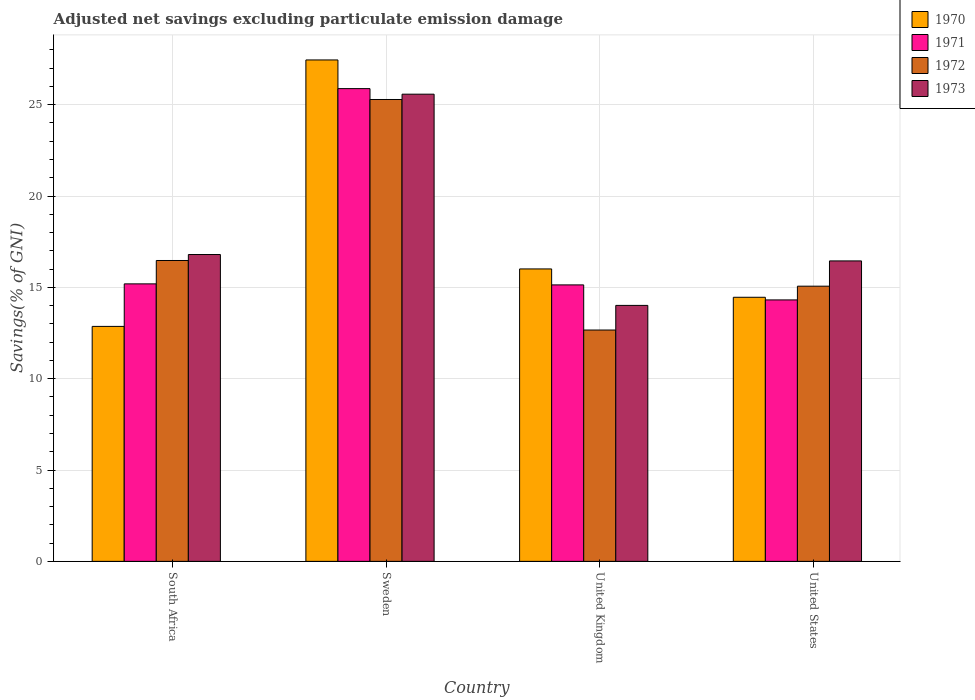How many groups of bars are there?
Your answer should be compact. 4. Are the number of bars per tick equal to the number of legend labels?
Provide a short and direct response. Yes. How many bars are there on the 2nd tick from the left?
Provide a short and direct response. 4. How many bars are there on the 2nd tick from the right?
Your answer should be very brief. 4. In how many cases, is the number of bars for a given country not equal to the number of legend labels?
Your response must be concise. 0. What is the adjusted net savings in 1972 in South Africa?
Offer a terse response. 16.47. Across all countries, what is the maximum adjusted net savings in 1972?
Make the answer very short. 25.28. Across all countries, what is the minimum adjusted net savings in 1971?
Offer a very short reply. 14.31. In which country was the adjusted net savings in 1970 minimum?
Your answer should be very brief. South Africa. What is the total adjusted net savings in 1971 in the graph?
Your response must be concise. 70.51. What is the difference between the adjusted net savings in 1973 in Sweden and that in United States?
Keep it short and to the point. 9.13. What is the difference between the adjusted net savings in 1971 in Sweden and the adjusted net savings in 1973 in United States?
Provide a succinct answer. 9.43. What is the average adjusted net savings in 1972 per country?
Make the answer very short. 17.37. What is the difference between the adjusted net savings of/in 1973 and adjusted net savings of/in 1971 in Sweden?
Ensure brevity in your answer.  -0.3. In how many countries, is the adjusted net savings in 1971 greater than 18 %?
Offer a terse response. 1. What is the ratio of the adjusted net savings in 1970 in South Africa to that in United Kingdom?
Keep it short and to the point. 0.8. Is the adjusted net savings in 1973 in South Africa less than that in Sweden?
Provide a short and direct response. Yes. Is the difference between the adjusted net savings in 1973 in South Africa and Sweden greater than the difference between the adjusted net savings in 1971 in South Africa and Sweden?
Offer a terse response. Yes. What is the difference between the highest and the second highest adjusted net savings in 1970?
Provide a short and direct response. -11.44. What is the difference between the highest and the lowest adjusted net savings in 1970?
Offer a very short reply. 14.59. In how many countries, is the adjusted net savings in 1970 greater than the average adjusted net savings in 1970 taken over all countries?
Provide a succinct answer. 1. What does the 1st bar from the right in United States represents?
Offer a very short reply. 1973. Is it the case that in every country, the sum of the adjusted net savings in 1973 and adjusted net savings in 1971 is greater than the adjusted net savings in 1970?
Your response must be concise. Yes. How many bars are there?
Give a very brief answer. 16. How many countries are there in the graph?
Give a very brief answer. 4. What is the difference between two consecutive major ticks on the Y-axis?
Offer a terse response. 5. Are the values on the major ticks of Y-axis written in scientific E-notation?
Provide a succinct answer. No. How are the legend labels stacked?
Keep it short and to the point. Vertical. What is the title of the graph?
Keep it short and to the point. Adjusted net savings excluding particulate emission damage. Does "1973" appear as one of the legend labels in the graph?
Provide a succinct answer. Yes. What is the label or title of the X-axis?
Provide a succinct answer. Country. What is the label or title of the Y-axis?
Offer a very short reply. Savings(% of GNI). What is the Savings(% of GNI) of 1970 in South Africa?
Your answer should be compact. 12.86. What is the Savings(% of GNI) of 1971 in South Africa?
Provide a short and direct response. 15.19. What is the Savings(% of GNI) of 1972 in South Africa?
Keep it short and to the point. 16.47. What is the Savings(% of GNI) of 1973 in South Africa?
Offer a very short reply. 16.8. What is the Savings(% of GNI) in 1970 in Sweden?
Provide a short and direct response. 27.45. What is the Savings(% of GNI) in 1971 in Sweden?
Your answer should be compact. 25.88. What is the Savings(% of GNI) of 1972 in Sweden?
Give a very brief answer. 25.28. What is the Savings(% of GNI) in 1973 in Sweden?
Your answer should be compact. 25.57. What is the Savings(% of GNI) of 1970 in United Kingdom?
Your response must be concise. 16.01. What is the Savings(% of GNI) in 1971 in United Kingdom?
Keep it short and to the point. 15.13. What is the Savings(% of GNI) in 1972 in United Kingdom?
Make the answer very short. 12.66. What is the Savings(% of GNI) of 1973 in United Kingdom?
Your answer should be very brief. 14.01. What is the Savings(% of GNI) in 1970 in United States?
Give a very brief answer. 14.46. What is the Savings(% of GNI) in 1971 in United States?
Offer a very short reply. 14.31. What is the Savings(% of GNI) in 1972 in United States?
Give a very brief answer. 15.06. What is the Savings(% of GNI) in 1973 in United States?
Give a very brief answer. 16.45. Across all countries, what is the maximum Savings(% of GNI) in 1970?
Ensure brevity in your answer.  27.45. Across all countries, what is the maximum Savings(% of GNI) of 1971?
Offer a terse response. 25.88. Across all countries, what is the maximum Savings(% of GNI) in 1972?
Provide a short and direct response. 25.28. Across all countries, what is the maximum Savings(% of GNI) of 1973?
Your answer should be compact. 25.57. Across all countries, what is the minimum Savings(% of GNI) of 1970?
Give a very brief answer. 12.86. Across all countries, what is the minimum Savings(% of GNI) of 1971?
Offer a very short reply. 14.31. Across all countries, what is the minimum Savings(% of GNI) in 1972?
Give a very brief answer. 12.66. Across all countries, what is the minimum Savings(% of GNI) in 1973?
Provide a succinct answer. 14.01. What is the total Savings(% of GNI) in 1970 in the graph?
Your answer should be very brief. 70.77. What is the total Savings(% of GNI) in 1971 in the graph?
Your answer should be very brief. 70.51. What is the total Savings(% of GNI) of 1972 in the graph?
Provide a succinct answer. 69.48. What is the total Savings(% of GNI) of 1973 in the graph?
Provide a succinct answer. 72.83. What is the difference between the Savings(% of GNI) of 1970 in South Africa and that in Sweden?
Offer a very short reply. -14.59. What is the difference between the Savings(% of GNI) in 1971 in South Africa and that in Sweden?
Provide a short and direct response. -10.69. What is the difference between the Savings(% of GNI) in 1972 in South Africa and that in Sweden?
Provide a short and direct response. -8.81. What is the difference between the Savings(% of GNI) of 1973 in South Africa and that in Sweden?
Offer a terse response. -8.78. What is the difference between the Savings(% of GNI) of 1970 in South Africa and that in United Kingdom?
Your response must be concise. -3.15. What is the difference between the Savings(% of GNI) of 1971 in South Africa and that in United Kingdom?
Keep it short and to the point. 0.06. What is the difference between the Savings(% of GNI) in 1972 in South Africa and that in United Kingdom?
Give a very brief answer. 3.81. What is the difference between the Savings(% of GNI) of 1973 in South Africa and that in United Kingdom?
Offer a very short reply. 2.78. What is the difference between the Savings(% of GNI) in 1970 in South Africa and that in United States?
Ensure brevity in your answer.  -1.59. What is the difference between the Savings(% of GNI) in 1971 in South Africa and that in United States?
Ensure brevity in your answer.  0.88. What is the difference between the Savings(% of GNI) in 1972 in South Africa and that in United States?
Offer a terse response. 1.41. What is the difference between the Savings(% of GNI) of 1973 in South Africa and that in United States?
Make the answer very short. 0.35. What is the difference between the Savings(% of GNI) in 1970 in Sweden and that in United Kingdom?
Your answer should be very brief. 11.44. What is the difference between the Savings(% of GNI) in 1971 in Sweden and that in United Kingdom?
Your response must be concise. 10.74. What is the difference between the Savings(% of GNI) of 1972 in Sweden and that in United Kingdom?
Provide a succinct answer. 12.62. What is the difference between the Savings(% of GNI) in 1973 in Sweden and that in United Kingdom?
Your response must be concise. 11.56. What is the difference between the Savings(% of GNI) of 1970 in Sweden and that in United States?
Give a very brief answer. 12.99. What is the difference between the Savings(% of GNI) of 1971 in Sweden and that in United States?
Provide a succinct answer. 11.57. What is the difference between the Savings(% of GNI) in 1972 in Sweden and that in United States?
Offer a very short reply. 10.22. What is the difference between the Savings(% of GNI) in 1973 in Sweden and that in United States?
Ensure brevity in your answer.  9.13. What is the difference between the Savings(% of GNI) in 1970 in United Kingdom and that in United States?
Keep it short and to the point. 1.55. What is the difference between the Savings(% of GNI) in 1971 in United Kingdom and that in United States?
Provide a succinct answer. 0.82. What is the difference between the Savings(% of GNI) in 1972 in United Kingdom and that in United States?
Your answer should be compact. -2.4. What is the difference between the Savings(% of GNI) in 1973 in United Kingdom and that in United States?
Provide a succinct answer. -2.43. What is the difference between the Savings(% of GNI) in 1970 in South Africa and the Savings(% of GNI) in 1971 in Sweden?
Ensure brevity in your answer.  -13.02. What is the difference between the Savings(% of GNI) in 1970 in South Africa and the Savings(% of GNI) in 1972 in Sweden?
Give a very brief answer. -12.42. What is the difference between the Savings(% of GNI) in 1970 in South Africa and the Savings(% of GNI) in 1973 in Sweden?
Ensure brevity in your answer.  -12.71. What is the difference between the Savings(% of GNI) in 1971 in South Africa and the Savings(% of GNI) in 1972 in Sweden?
Offer a very short reply. -10.09. What is the difference between the Savings(% of GNI) of 1971 in South Africa and the Savings(% of GNI) of 1973 in Sweden?
Your response must be concise. -10.38. What is the difference between the Savings(% of GNI) in 1972 in South Africa and the Savings(% of GNI) in 1973 in Sweden?
Keep it short and to the point. -9.1. What is the difference between the Savings(% of GNI) in 1970 in South Africa and the Savings(% of GNI) in 1971 in United Kingdom?
Offer a very short reply. -2.27. What is the difference between the Savings(% of GNI) in 1970 in South Africa and the Savings(% of GNI) in 1972 in United Kingdom?
Your answer should be compact. 0.2. What is the difference between the Savings(% of GNI) in 1970 in South Africa and the Savings(% of GNI) in 1973 in United Kingdom?
Provide a succinct answer. -1.15. What is the difference between the Savings(% of GNI) in 1971 in South Africa and the Savings(% of GNI) in 1972 in United Kingdom?
Provide a succinct answer. 2.53. What is the difference between the Savings(% of GNI) in 1971 in South Africa and the Savings(% of GNI) in 1973 in United Kingdom?
Keep it short and to the point. 1.18. What is the difference between the Savings(% of GNI) of 1972 in South Africa and the Savings(% of GNI) of 1973 in United Kingdom?
Keep it short and to the point. 2.46. What is the difference between the Savings(% of GNI) in 1970 in South Africa and the Savings(% of GNI) in 1971 in United States?
Offer a terse response. -1.45. What is the difference between the Savings(% of GNI) in 1970 in South Africa and the Savings(% of GNI) in 1972 in United States?
Keep it short and to the point. -2.2. What is the difference between the Savings(% of GNI) of 1970 in South Africa and the Savings(% of GNI) of 1973 in United States?
Keep it short and to the point. -3.58. What is the difference between the Savings(% of GNI) in 1971 in South Africa and the Savings(% of GNI) in 1972 in United States?
Your answer should be compact. 0.13. What is the difference between the Savings(% of GNI) in 1971 in South Africa and the Savings(% of GNI) in 1973 in United States?
Provide a short and direct response. -1.26. What is the difference between the Savings(% of GNI) in 1972 in South Africa and the Savings(% of GNI) in 1973 in United States?
Provide a short and direct response. 0.02. What is the difference between the Savings(% of GNI) in 1970 in Sweden and the Savings(% of GNI) in 1971 in United Kingdom?
Make the answer very short. 12.31. What is the difference between the Savings(% of GNI) in 1970 in Sweden and the Savings(% of GNI) in 1972 in United Kingdom?
Your answer should be compact. 14.78. What is the difference between the Savings(% of GNI) of 1970 in Sweden and the Savings(% of GNI) of 1973 in United Kingdom?
Provide a short and direct response. 13.44. What is the difference between the Savings(% of GNI) in 1971 in Sweden and the Savings(% of GNI) in 1972 in United Kingdom?
Ensure brevity in your answer.  13.21. What is the difference between the Savings(% of GNI) in 1971 in Sweden and the Savings(% of GNI) in 1973 in United Kingdom?
Give a very brief answer. 11.87. What is the difference between the Savings(% of GNI) in 1972 in Sweden and the Savings(% of GNI) in 1973 in United Kingdom?
Offer a terse response. 11.27. What is the difference between the Savings(% of GNI) of 1970 in Sweden and the Savings(% of GNI) of 1971 in United States?
Give a very brief answer. 13.14. What is the difference between the Savings(% of GNI) in 1970 in Sweden and the Savings(% of GNI) in 1972 in United States?
Your answer should be compact. 12.38. What is the difference between the Savings(% of GNI) in 1970 in Sweden and the Savings(% of GNI) in 1973 in United States?
Provide a short and direct response. 11. What is the difference between the Savings(% of GNI) of 1971 in Sweden and the Savings(% of GNI) of 1972 in United States?
Provide a short and direct response. 10.81. What is the difference between the Savings(% of GNI) of 1971 in Sweden and the Savings(% of GNI) of 1973 in United States?
Ensure brevity in your answer.  9.43. What is the difference between the Savings(% of GNI) in 1972 in Sweden and the Savings(% of GNI) in 1973 in United States?
Make the answer very short. 8.84. What is the difference between the Savings(% of GNI) in 1970 in United Kingdom and the Savings(% of GNI) in 1971 in United States?
Keep it short and to the point. 1.7. What is the difference between the Savings(% of GNI) of 1970 in United Kingdom and the Savings(% of GNI) of 1972 in United States?
Your answer should be very brief. 0.94. What is the difference between the Savings(% of GNI) in 1970 in United Kingdom and the Savings(% of GNI) in 1973 in United States?
Your answer should be very brief. -0.44. What is the difference between the Savings(% of GNI) in 1971 in United Kingdom and the Savings(% of GNI) in 1972 in United States?
Your answer should be compact. 0.07. What is the difference between the Savings(% of GNI) in 1971 in United Kingdom and the Savings(% of GNI) in 1973 in United States?
Offer a very short reply. -1.31. What is the difference between the Savings(% of GNI) in 1972 in United Kingdom and the Savings(% of GNI) in 1973 in United States?
Offer a very short reply. -3.78. What is the average Savings(% of GNI) in 1970 per country?
Ensure brevity in your answer.  17.69. What is the average Savings(% of GNI) of 1971 per country?
Provide a short and direct response. 17.63. What is the average Savings(% of GNI) in 1972 per country?
Your response must be concise. 17.37. What is the average Savings(% of GNI) in 1973 per country?
Make the answer very short. 18.21. What is the difference between the Savings(% of GNI) of 1970 and Savings(% of GNI) of 1971 in South Africa?
Make the answer very short. -2.33. What is the difference between the Savings(% of GNI) of 1970 and Savings(% of GNI) of 1972 in South Africa?
Offer a very short reply. -3.61. What is the difference between the Savings(% of GNI) of 1970 and Savings(% of GNI) of 1973 in South Africa?
Ensure brevity in your answer.  -3.93. What is the difference between the Savings(% of GNI) in 1971 and Savings(% of GNI) in 1972 in South Africa?
Keep it short and to the point. -1.28. What is the difference between the Savings(% of GNI) in 1971 and Savings(% of GNI) in 1973 in South Africa?
Your response must be concise. -1.61. What is the difference between the Savings(% of GNI) in 1972 and Savings(% of GNI) in 1973 in South Africa?
Offer a very short reply. -0.33. What is the difference between the Savings(% of GNI) of 1970 and Savings(% of GNI) of 1971 in Sweden?
Make the answer very short. 1.57. What is the difference between the Savings(% of GNI) in 1970 and Savings(% of GNI) in 1972 in Sweden?
Provide a succinct answer. 2.16. What is the difference between the Savings(% of GNI) of 1970 and Savings(% of GNI) of 1973 in Sweden?
Your response must be concise. 1.87. What is the difference between the Savings(% of GNI) in 1971 and Savings(% of GNI) in 1972 in Sweden?
Your response must be concise. 0.59. What is the difference between the Savings(% of GNI) in 1971 and Savings(% of GNI) in 1973 in Sweden?
Offer a terse response. 0.3. What is the difference between the Savings(% of GNI) of 1972 and Savings(% of GNI) of 1973 in Sweden?
Give a very brief answer. -0.29. What is the difference between the Savings(% of GNI) of 1970 and Savings(% of GNI) of 1971 in United Kingdom?
Keep it short and to the point. 0.87. What is the difference between the Savings(% of GNI) in 1970 and Savings(% of GNI) in 1972 in United Kingdom?
Give a very brief answer. 3.34. What is the difference between the Savings(% of GNI) in 1970 and Savings(% of GNI) in 1973 in United Kingdom?
Ensure brevity in your answer.  2. What is the difference between the Savings(% of GNI) in 1971 and Savings(% of GNI) in 1972 in United Kingdom?
Provide a short and direct response. 2.47. What is the difference between the Savings(% of GNI) of 1971 and Savings(% of GNI) of 1973 in United Kingdom?
Offer a terse response. 1.12. What is the difference between the Savings(% of GNI) in 1972 and Savings(% of GNI) in 1973 in United Kingdom?
Keep it short and to the point. -1.35. What is the difference between the Savings(% of GNI) of 1970 and Savings(% of GNI) of 1971 in United States?
Your answer should be very brief. 0.14. What is the difference between the Savings(% of GNI) of 1970 and Savings(% of GNI) of 1972 in United States?
Make the answer very short. -0.61. What is the difference between the Savings(% of GNI) of 1970 and Savings(% of GNI) of 1973 in United States?
Give a very brief answer. -1.99. What is the difference between the Savings(% of GNI) of 1971 and Savings(% of GNI) of 1972 in United States?
Keep it short and to the point. -0.75. What is the difference between the Savings(% of GNI) in 1971 and Savings(% of GNI) in 1973 in United States?
Offer a very short reply. -2.13. What is the difference between the Savings(% of GNI) of 1972 and Savings(% of GNI) of 1973 in United States?
Offer a very short reply. -1.38. What is the ratio of the Savings(% of GNI) in 1970 in South Africa to that in Sweden?
Provide a succinct answer. 0.47. What is the ratio of the Savings(% of GNI) of 1971 in South Africa to that in Sweden?
Provide a succinct answer. 0.59. What is the ratio of the Savings(% of GNI) of 1972 in South Africa to that in Sweden?
Provide a succinct answer. 0.65. What is the ratio of the Savings(% of GNI) of 1973 in South Africa to that in Sweden?
Provide a succinct answer. 0.66. What is the ratio of the Savings(% of GNI) in 1970 in South Africa to that in United Kingdom?
Make the answer very short. 0.8. What is the ratio of the Savings(% of GNI) of 1972 in South Africa to that in United Kingdom?
Your response must be concise. 1.3. What is the ratio of the Savings(% of GNI) in 1973 in South Africa to that in United Kingdom?
Your response must be concise. 1.2. What is the ratio of the Savings(% of GNI) in 1970 in South Africa to that in United States?
Provide a short and direct response. 0.89. What is the ratio of the Savings(% of GNI) in 1971 in South Africa to that in United States?
Offer a terse response. 1.06. What is the ratio of the Savings(% of GNI) in 1972 in South Africa to that in United States?
Give a very brief answer. 1.09. What is the ratio of the Savings(% of GNI) in 1973 in South Africa to that in United States?
Your answer should be very brief. 1.02. What is the ratio of the Savings(% of GNI) in 1970 in Sweden to that in United Kingdom?
Offer a very short reply. 1.71. What is the ratio of the Savings(% of GNI) of 1971 in Sweden to that in United Kingdom?
Your answer should be very brief. 1.71. What is the ratio of the Savings(% of GNI) of 1972 in Sweden to that in United Kingdom?
Give a very brief answer. 2. What is the ratio of the Savings(% of GNI) in 1973 in Sweden to that in United Kingdom?
Make the answer very short. 1.83. What is the ratio of the Savings(% of GNI) of 1970 in Sweden to that in United States?
Keep it short and to the point. 1.9. What is the ratio of the Savings(% of GNI) in 1971 in Sweden to that in United States?
Offer a very short reply. 1.81. What is the ratio of the Savings(% of GNI) of 1972 in Sweden to that in United States?
Keep it short and to the point. 1.68. What is the ratio of the Savings(% of GNI) in 1973 in Sweden to that in United States?
Offer a very short reply. 1.55. What is the ratio of the Savings(% of GNI) in 1970 in United Kingdom to that in United States?
Give a very brief answer. 1.11. What is the ratio of the Savings(% of GNI) of 1971 in United Kingdom to that in United States?
Your answer should be very brief. 1.06. What is the ratio of the Savings(% of GNI) in 1972 in United Kingdom to that in United States?
Your response must be concise. 0.84. What is the ratio of the Savings(% of GNI) of 1973 in United Kingdom to that in United States?
Your response must be concise. 0.85. What is the difference between the highest and the second highest Savings(% of GNI) of 1970?
Give a very brief answer. 11.44. What is the difference between the highest and the second highest Savings(% of GNI) in 1971?
Give a very brief answer. 10.69. What is the difference between the highest and the second highest Savings(% of GNI) of 1972?
Provide a short and direct response. 8.81. What is the difference between the highest and the second highest Savings(% of GNI) of 1973?
Provide a short and direct response. 8.78. What is the difference between the highest and the lowest Savings(% of GNI) of 1970?
Provide a short and direct response. 14.59. What is the difference between the highest and the lowest Savings(% of GNI) in 1971?
Make the answer very short. 11.57. What is the difference between the highest and the lowest Savings(% of GNI) in 1972?
Make the answer very short. 12.62. What is the difference between the highest and the lowest Savings(% of GNI) of 1973?
Provide a short and direct response. 11.56. 